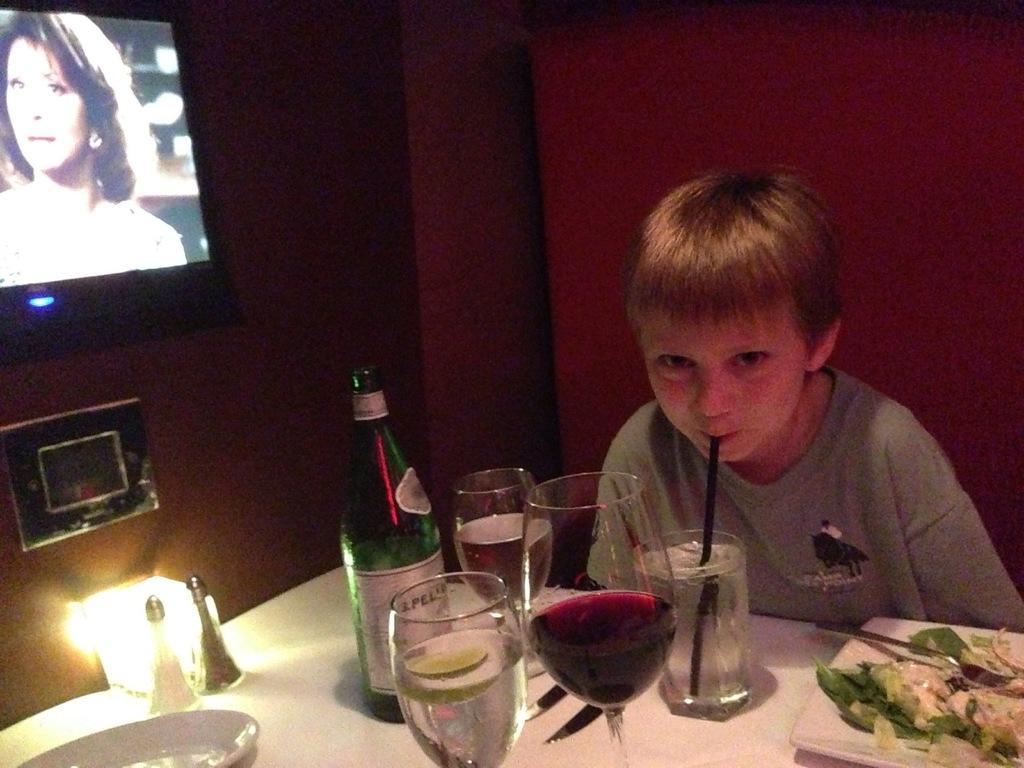Describe this image in one or two sentences. In this picture we can see a boy, in front of him we can see few glasses, bottle, plates, light an other things on the table, beside to him we can see a television on the wall. 